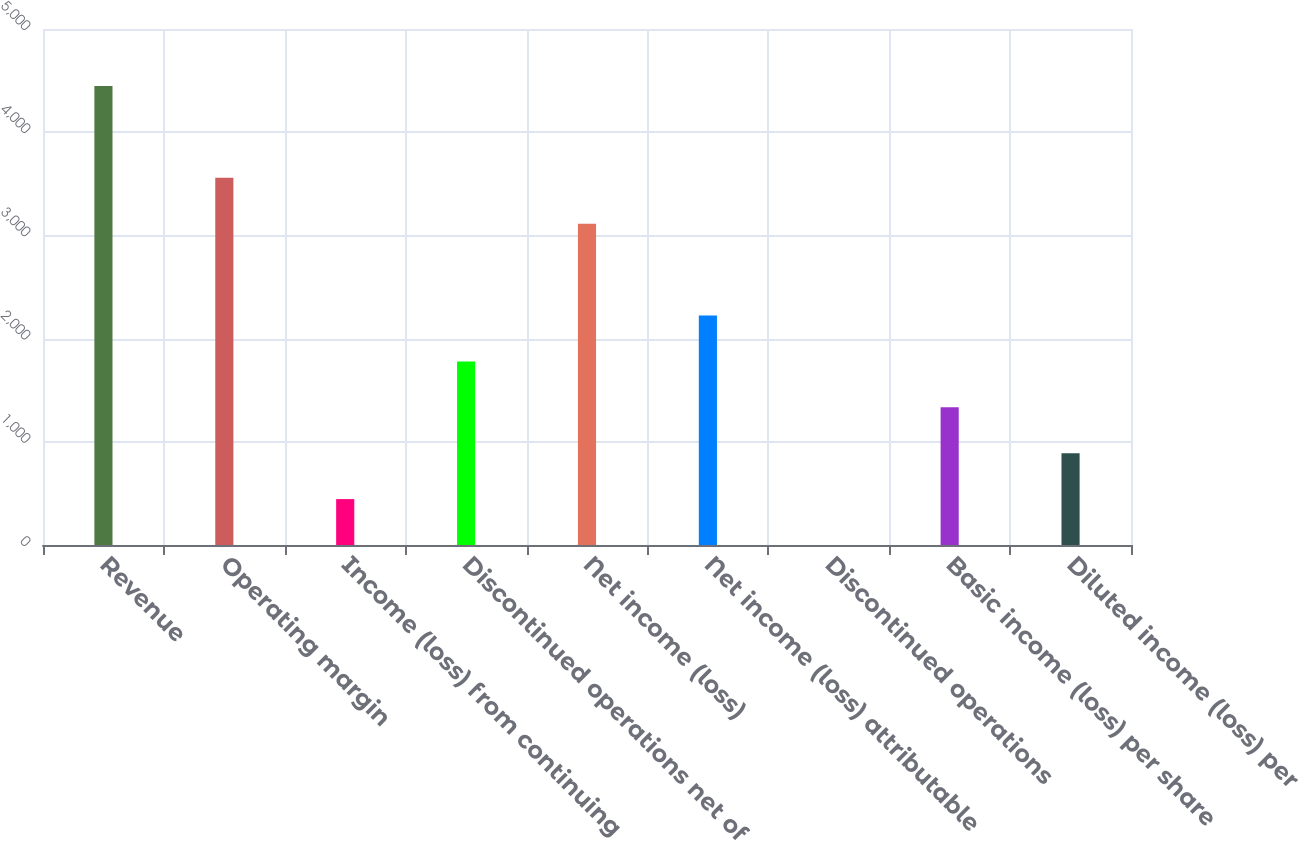Convert chart. <chart><loc_0><loc_0><loc_500><loc_500><bar_chart><fcel>Revenue<fcel>Operating margin<fcel>Income (loss) from continuing<fcel>Discontinued operations net of<fcel>Net income (loss)<fcel>Net income (loss) attributable<fcel>Discontinued operations<fcel>Basic income (loss) per share<fcel>Diluted income (loss) per<nl><fcel>4448<fcel>3558.42<fcel>444.82<fcel>1779.22<fcel>3113.62<fcel>2224.02<fcel>0.02<fcel>1334.42<fcel>889.62<nl></chart> 